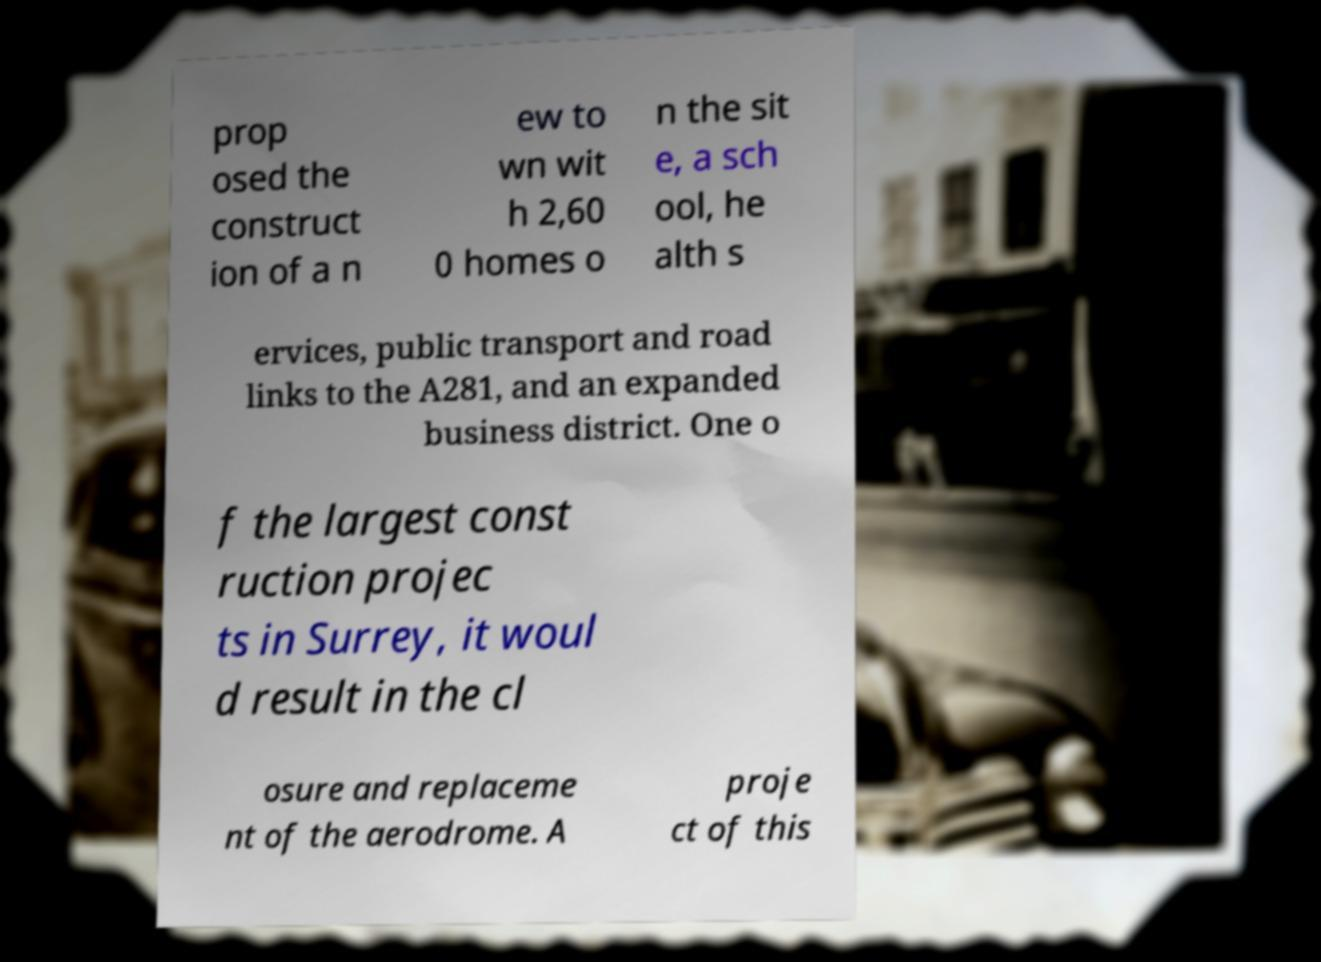For documentation purposes, I need the text within this image transcribed. Could you provide that? prop osed the construct ion of a n ew to wn wit h 2,60 0 homes o n the sit e, a sch ool, he alth s ervices, public transport and road links to the A281, and an expanded business district. One o f the largest const ruction projec ts in Surrey, it woul d result in the cl osure and replaceme nt of the aerodrome. A proje ct of this 